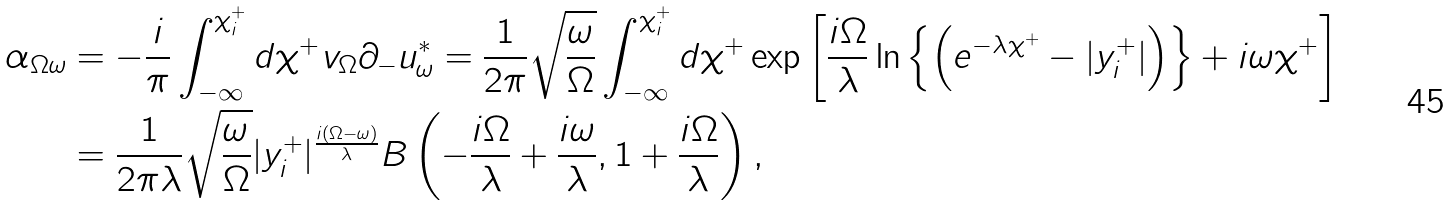<formula> <loc_0><loc_0><loc_500><loc_500>\alpha _ { \Omega \omega } & = - \frac { i } { \pi } \int _ { - \infty } ^ { \chi _ { i } ^ { + } } d \chi ^ { + } v _ { \Omega } \partial _ { - } u _ { \omega } ^ { * } = \frac { 1 } { 2 \pi } \sqrt { \frac { \omega } { \Omega } } \int _ { - \infty } ^ { \chi _ { i } ^ { + } } d \chi ^ { + } \exp \left [ \frac { i \Omega } { \lambda } \ln \left \{ \left ( e ^ { - \lambda \chi ^ { + } } - | y _ { i } ^ { + } | \right ) \right \} + i \omega \chi ^ { + } \right ] \\ & = \frac { 1 } { 2 \pi \lambda } \sqrt { \frac { \omega } { \Omega } } | y _ { i } ^ { + } | ^ { \frac { i ( \Omega - \omega ) } { \lambda } } B \left ( - \frac { i \Omega } { \lambda } + \frac { i \omega } { \lambda } , 1 + \frac { i \Omega } { \lambda } \right ) ,</formula> 